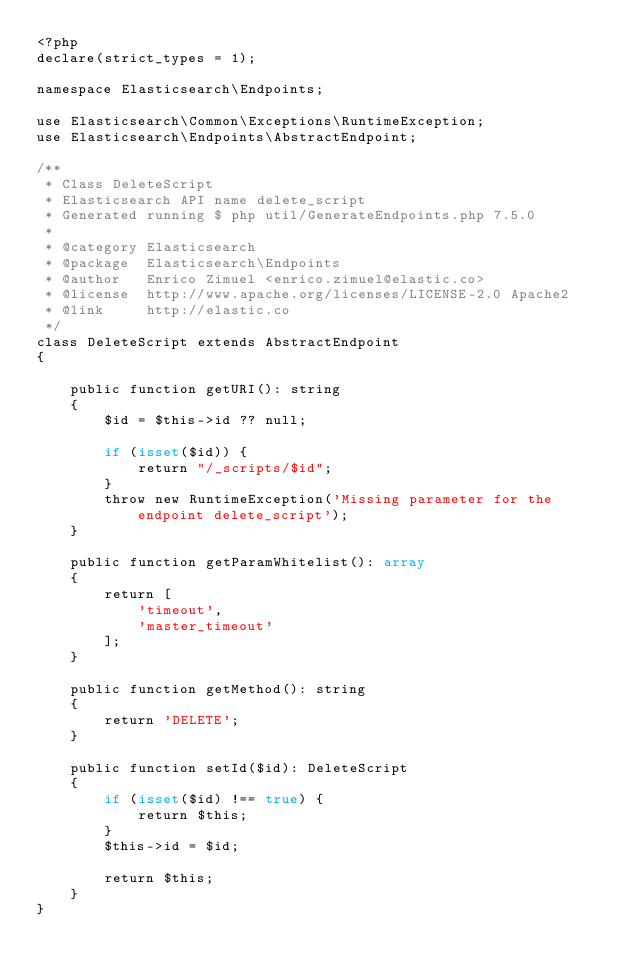<code> <loc_0><loc_0><loc_500><loc_500><_PHP_><?php
declare(strict_types = 1);

namespace Elasticsearch\Endpoints;

use Elasticsearch\Common\Exceptions\RuntimeException;
use Elasticsearch\Endpoints\AbstractEndpoint;

/**
 * Class DeleteScript
 * Elasticsearch API name delete_script
 * Generated running $ php util/GenerateEndpoints.php 7.5.0
 *
 * @category Elasticsearch
 * @package  Elasticsearch\Endpoints
 * @author   Enrico Zimuel <enrico.zimuel@elastic.co>
 * @license  http://www.apache.org/licenses/LICENSE-2.0 Apache2
 * @link     http://elastic.co
 */
class DeleteScript extends AbstractEndpoint
{

    public function getURI(): string
    {
        $id = $this->id ?? null;

        if (isset($id)) {
            return "/_scripts/$id";
        }
        throw new RuntimeException('Missing parameter for the endpoint delete_script');
    }

    public function getParamWhitelist(): array
    {
        return [
            'timeout',
            'master_timeout'
        ];
    }

    public function getMethod(): string
    {
        return 'DELETE';
    }

    public function setId($id): DeleteScript
    {
        if (isset($id) !== true) {
            return $this;
        }
        $this->id = $id;

        return $this;
    }
}
</code> 